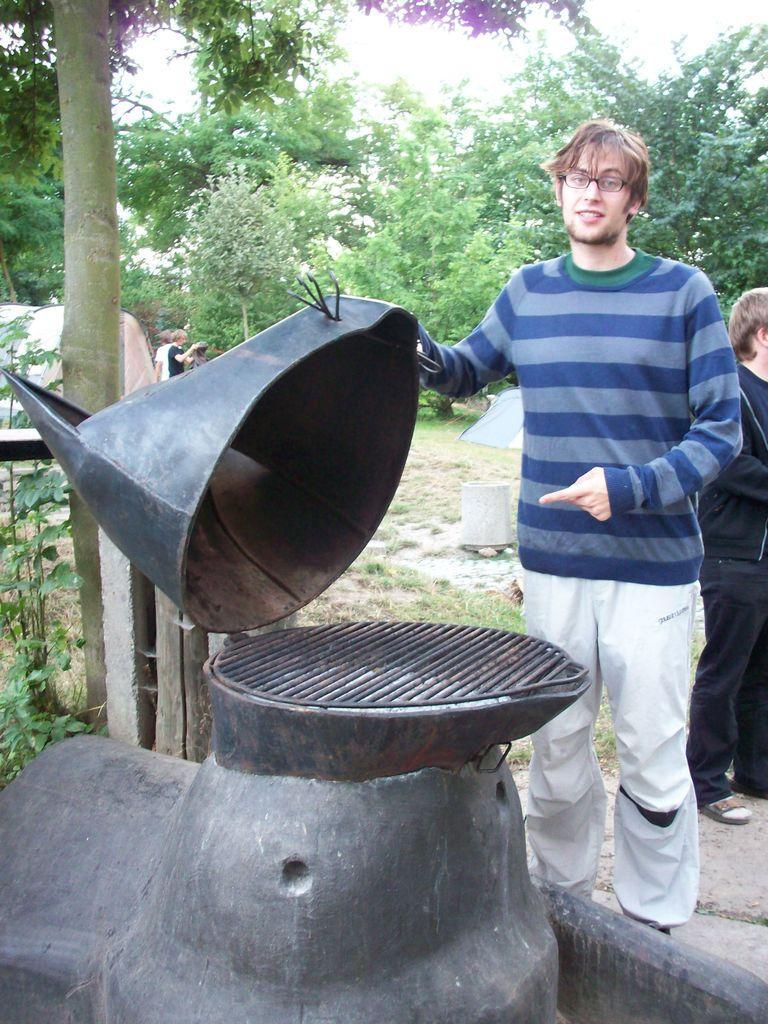Describe this image in one or two sentences. In this image, we can see a man standing and he is holding an object, on the right side, we can see a person standing behind the man, we can see some trees in the background. 